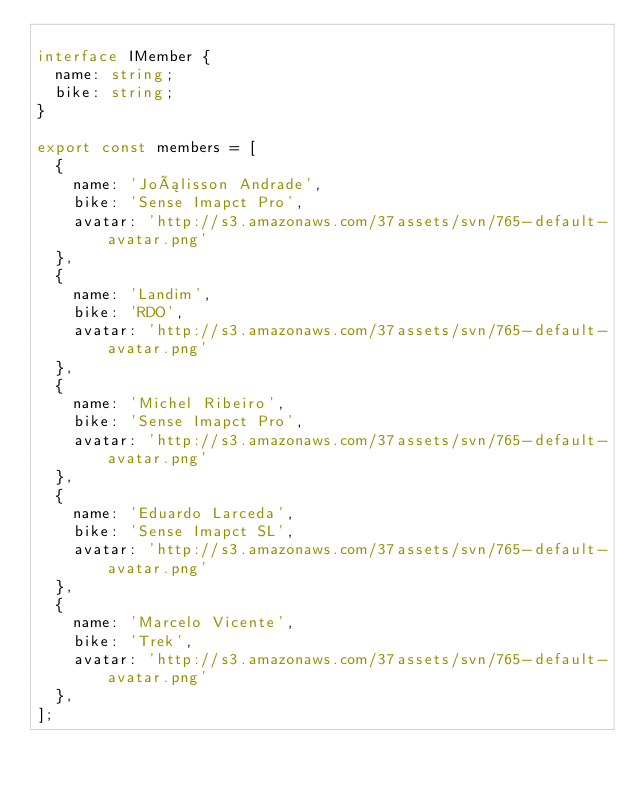Convert code to text. <code><loc_0><loc_0><loc_500><loc_500><_TypeScript_>
interface IMember {
  name: string;
  bike: string;
}

export const members = [
  {
    name: 'Joálisson Andrade',
    bike: 'Sense Imapct Pro',
    avatar: 'http://s3.amazonaws.com/37assets/svn/765-default-avatar.png'
  },
  {
    name: 'Landim',
    bike: 'RDO',
    avatar: 'http://s3.amazonaws.com/37assets/svn/765-default-avatar.png'
  },
  {
    name: 'Michel Ribeiro',
    bike: 'Sense Imapct Pro',
    avatar: 'http://s3.amazonaws.com/37assets/svn/765-default-avatar.png'
  },
  {
    name: 'Eduardo Larceda',
    bike: 'Sense Imapct SL',
    avatar: 'http://s3.amazonaws.com/37assets/svn/765-default-avatar.png'
  },
  {
    name: 'Marcelo Vicente',
    bike: 'Trek',
    avatar: 'http://s3.amazonaws.com/37assets/svn/765-default-avatar.png'
  },
];
</code> 